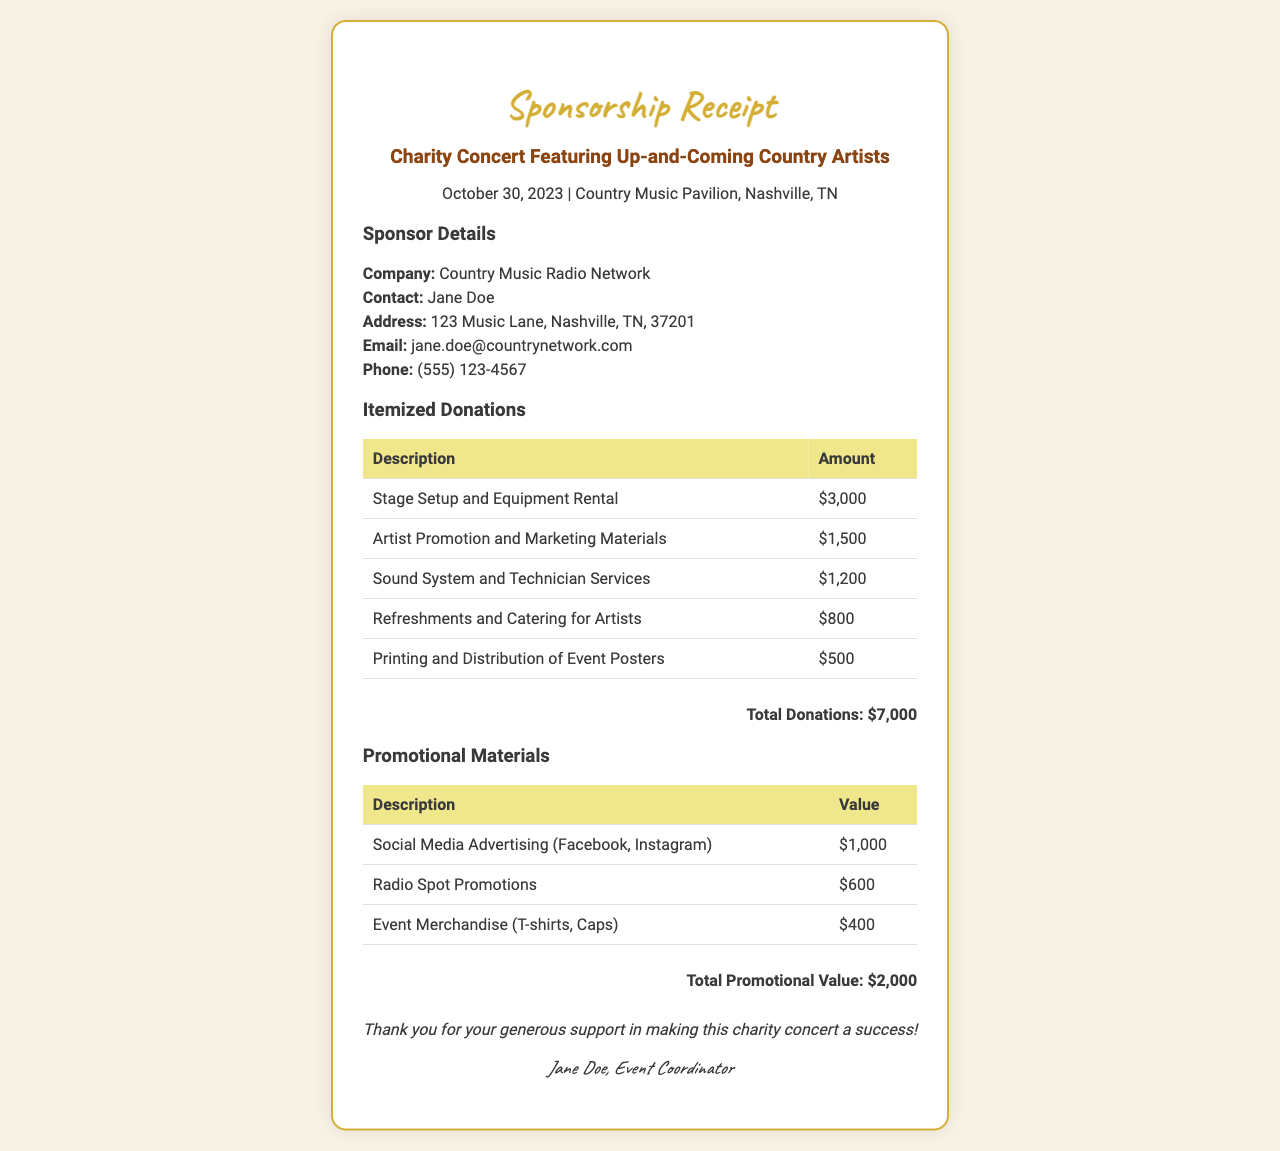What is the date of the concert? The date of the concert is mentioned in the document as October 30, 2023.
Answer: October 30, 2023 Who is the contact person for the sponsorship? The contact person is listed in the document as Jane Doe.
Answer: Jane Doe What is the total amount of itemized donations? The total of the itemized donations is provided in the document as $7,000.
Answer: $7,000 How much was spent on sound system and technician services? The amount spent on sound system and technician services is found in the itemized donations table as $1,200.
Answer: $1,200 What is the total value of promotional materials? The total value of promotional materials is given in the document as $2,000.
Answer: $2,000 What is the address of the sponsoring company? The address of the sponsoring company is stated as 123 Music Lane, Nashville, TN, 37201.
Answer: 123 Music Lane, Nashville, TN, 37201 How much was allocated for artist promotion and marketing materials? The document lists the allocation for artist promotion and marketing materials as $1,500.
Answer: $1,500 What type of event is this receipt for? The event type is a charity concert featuring up-and-coming country artists.
Answer: Charity concert What type of promotional material received the highest value? The highest value promotional material is social media advertising worth $1,000.
Answer: Social Media Advertising (Facebook, Instagram) Who signed the receipt? The signature at the end of the receipt indicates that Jane Doe, the event coordinator, signed it.
Answer: Jane Doe, Event Coordinator 